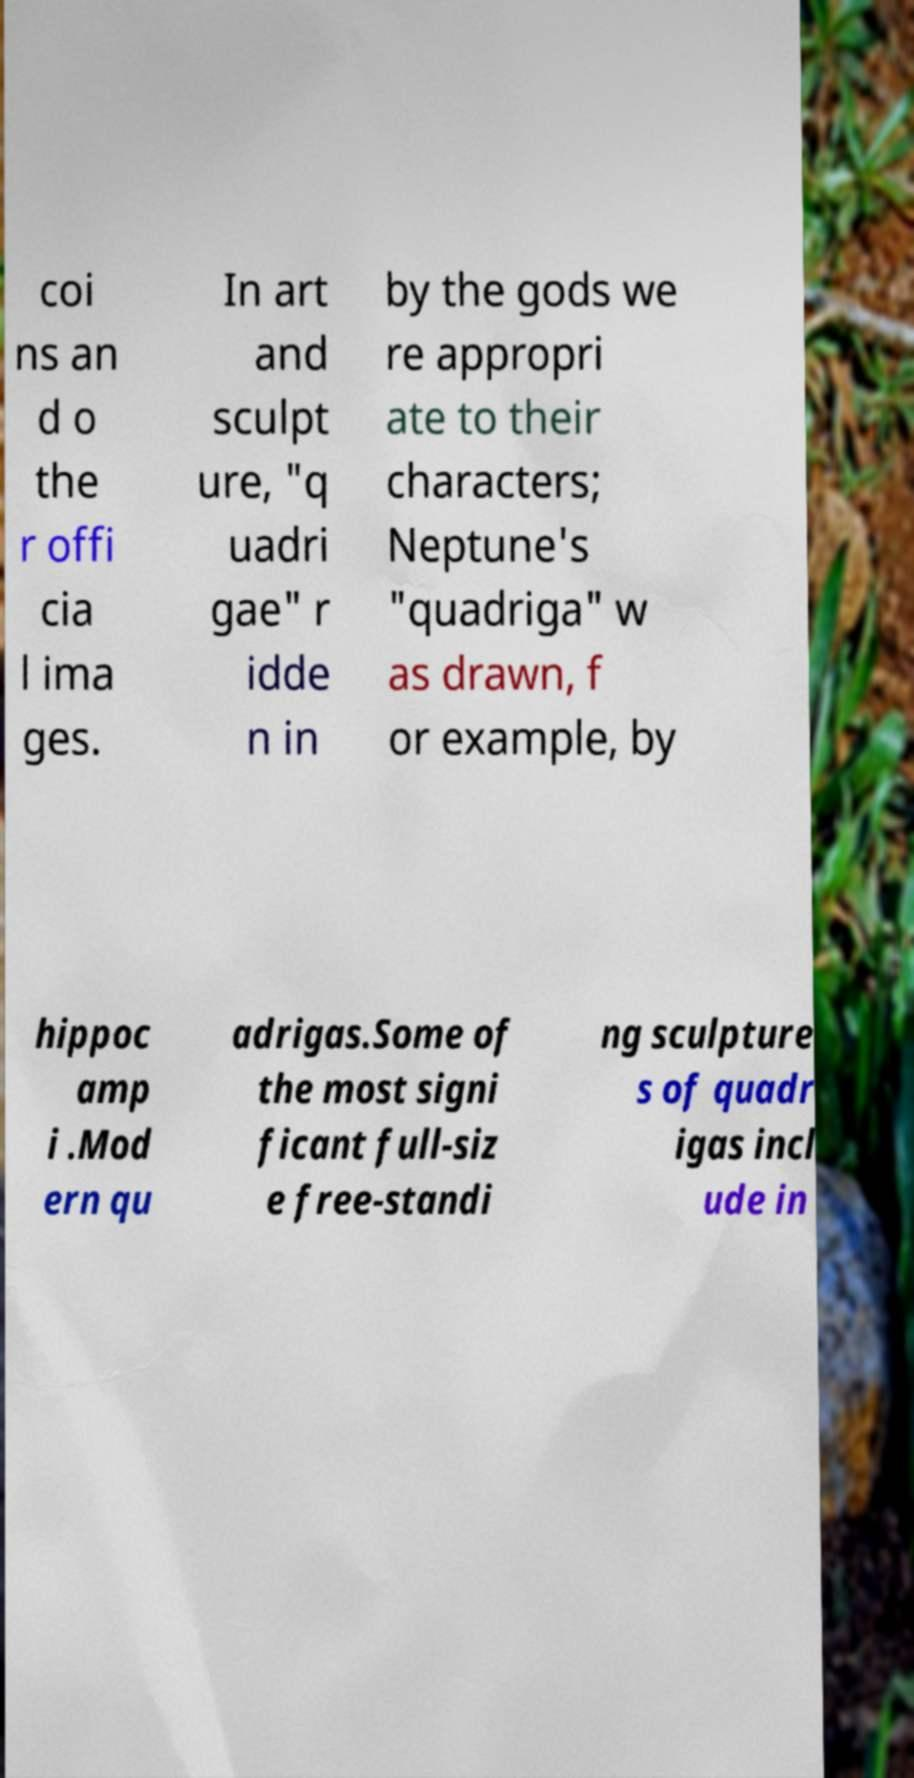I need the written content from this picture converted into text. Can you do that? coi ns an d o the r offi cia l ima ges. In art and sculpt ure, "q uadri gae" r idde n in by the gods we re appropri ate to their characters; Neptune's "quadriga" w as drawn, f or example, by hippoc amp i .Mod ern qu adrigas.Some of the most signi ficant full-siz e free-standi ng sculpture s of quadr igas incl ude in 